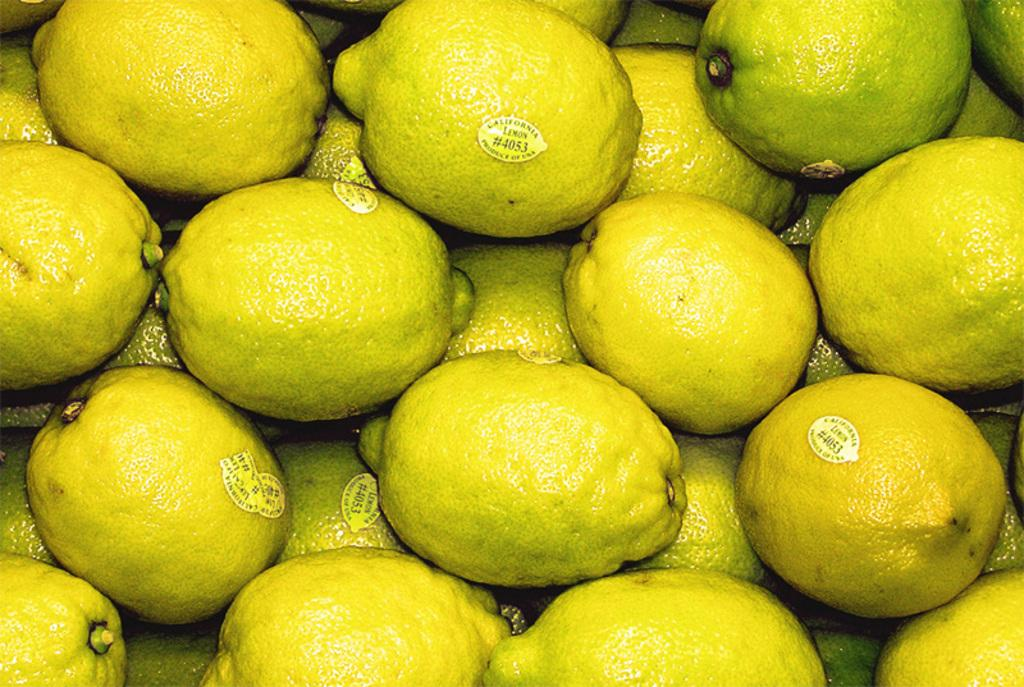What type of fruit is present in the image? There are lemons in the image. Are there any distinguishing features on the lemons? Yes, the lemons have stickers on them. What is the result of the competition that took place downtown in the image? There is no competition or downtown location mentioned in the image; it only features lemons with stickers on them. 